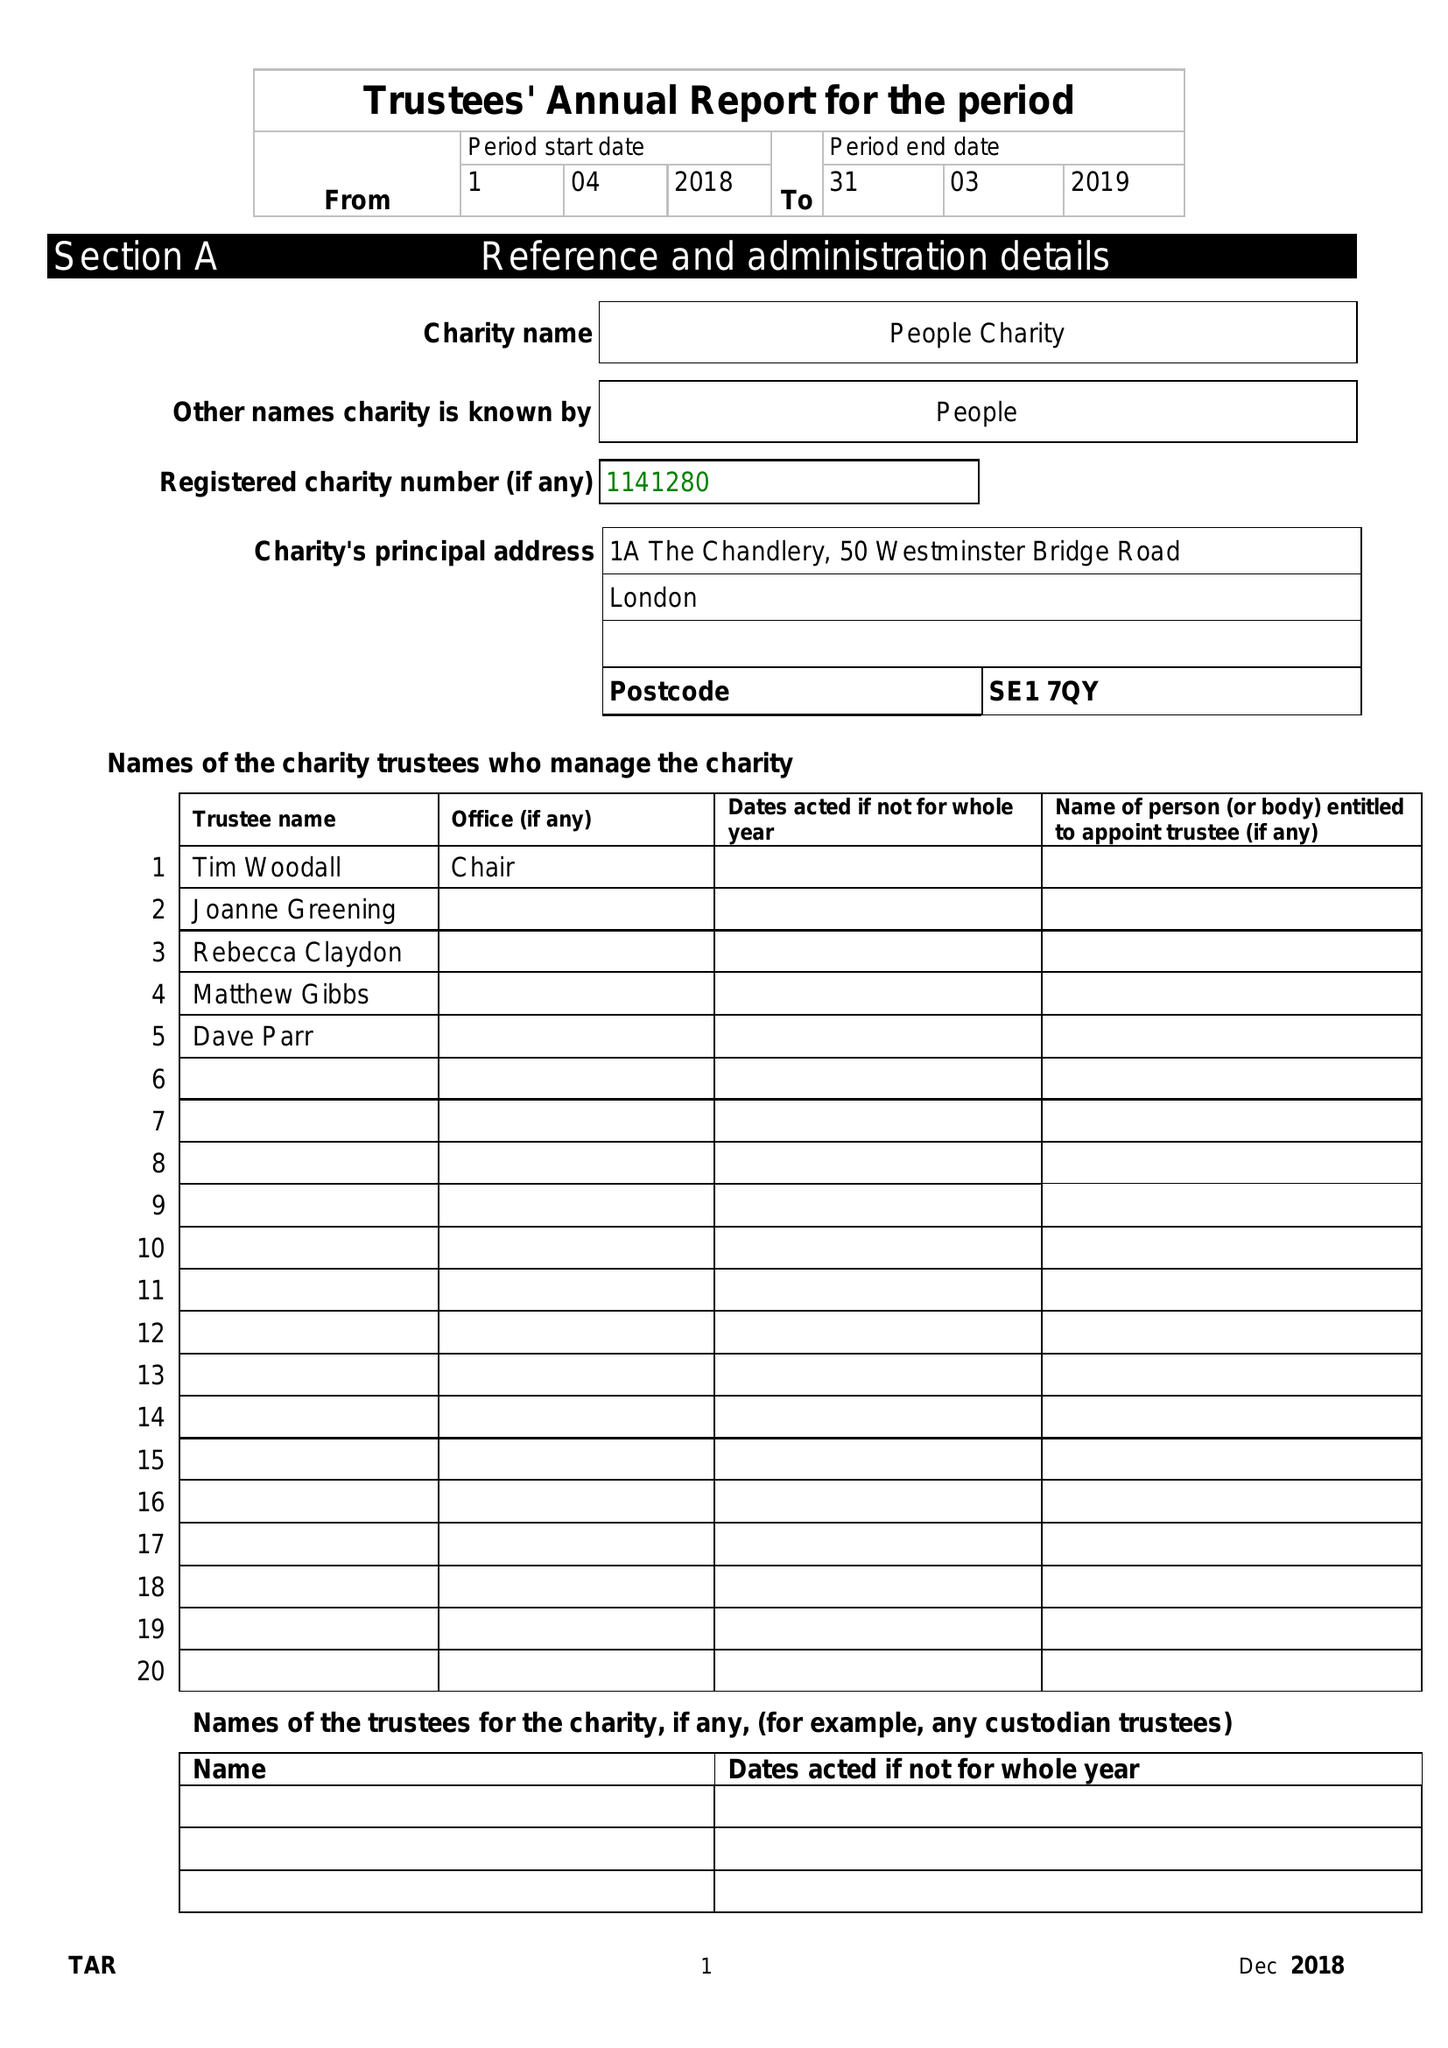What is the value for the spending_annually_in_british_pounds?
Answer the question using a single word or phrase. 48448.00 